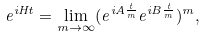<formula> <loc_0><loc_0><loc_500><loc_500>e ^ { i H t } = \lim _ { m \rightarrow \infty } ( e ^ { i A \frac { t } { m } } e ^ { i B \frac { t } { m } } ) ^ { m } ,</formula> 